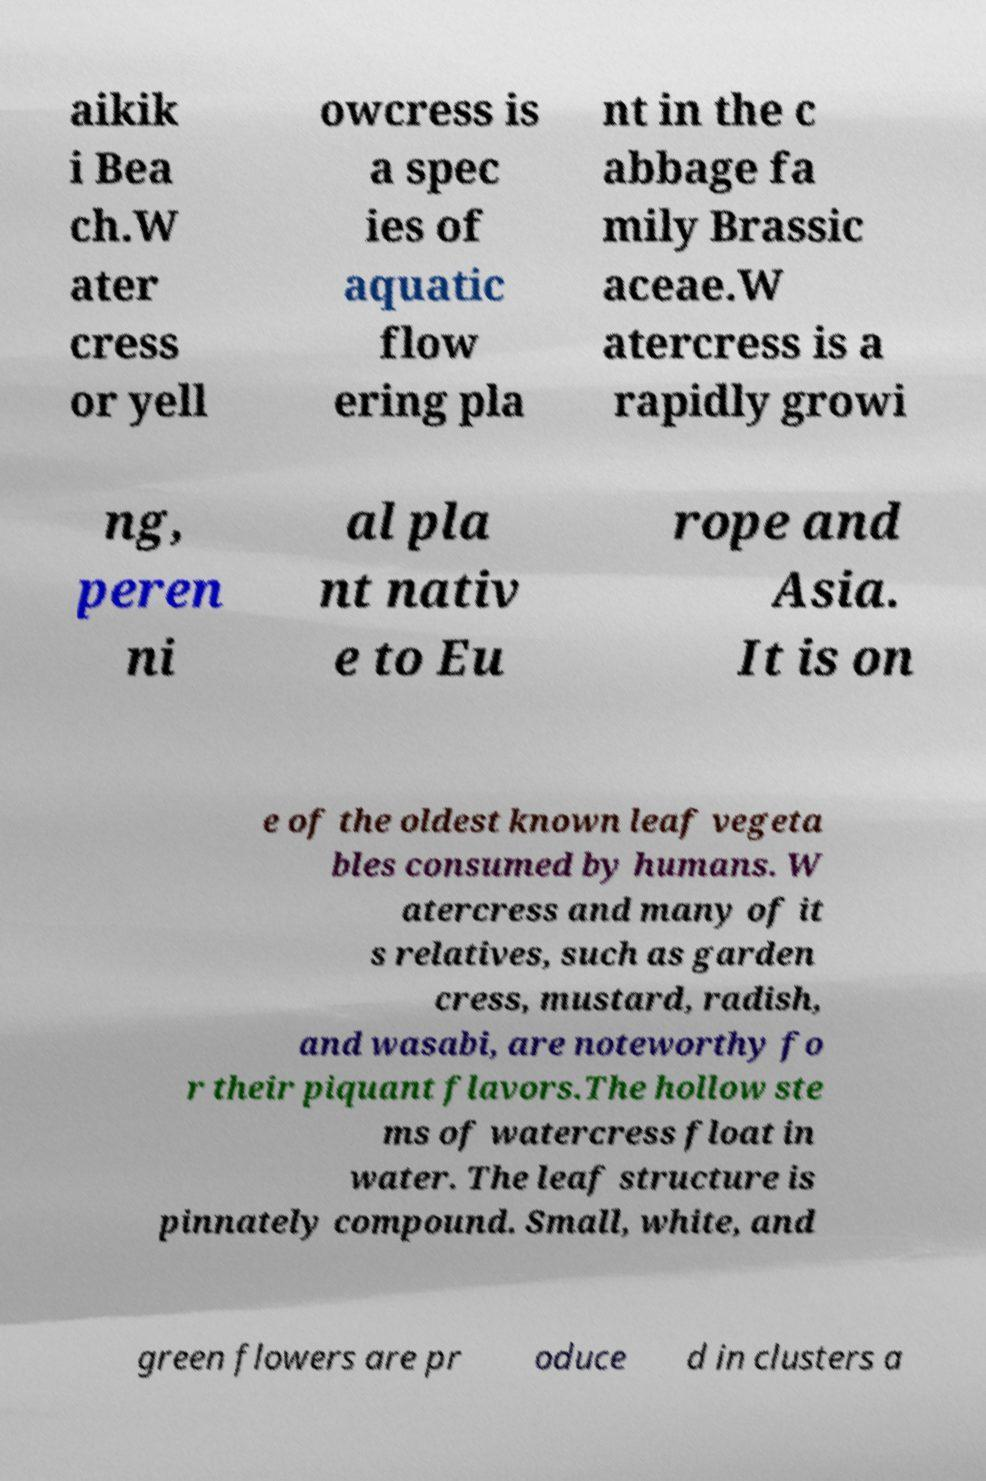Could you extract and type out the text from this image? aikik i Bea ch.W ater cress or yell owcress is a spec ies of aquatic flow ering pla nt in the c abbage fa mily Brassic aceae.W atercress is a rapidly growi ng, peren ni al pla nt nativ e to Eu rope and Asia. It is on e of the oldest known leaf vegeta bles consumed by humans. W atercress and many of it s relatives, such as garden cress, mustard, radish, and wasabi, are noteworthy fo r their piquant flavors.The hollow ste ms of watercress float in water. The leaf structure is pinnately compound. Small, white, and green flowers are pr oduce d in clusters a 